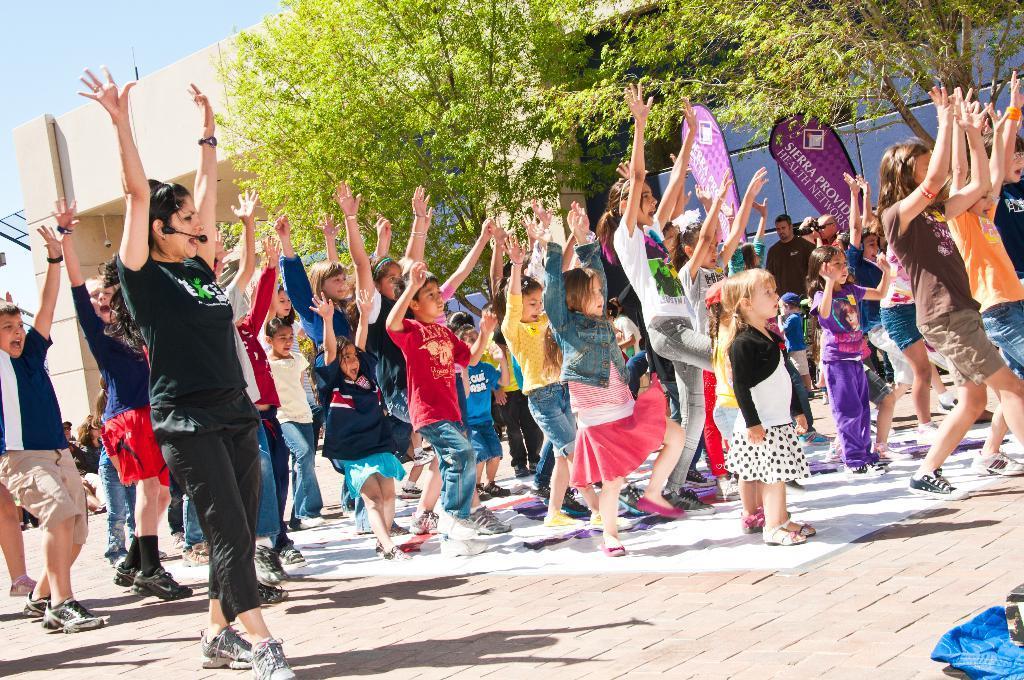Please provide a concise description of this image. In this picture I can see group of people standing, there are advertising flags, trees, this is looking like a house, and in the background there is sky. 